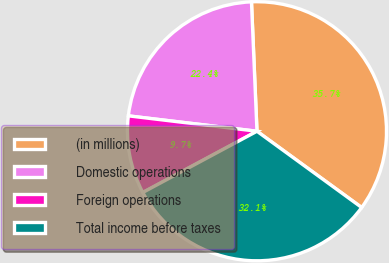Convert chart. <chart><loc_0><loc_0><loc_500><loc_500><pie_chart><fcel>(in millions)<fcel>Domestic operations<fcel>Foreign operations<fcel>Total income before taxes<nl><fcel>35.7%<fcel>22.43%<fcel>9.73%<fcel>32.15%<nl></chart> 